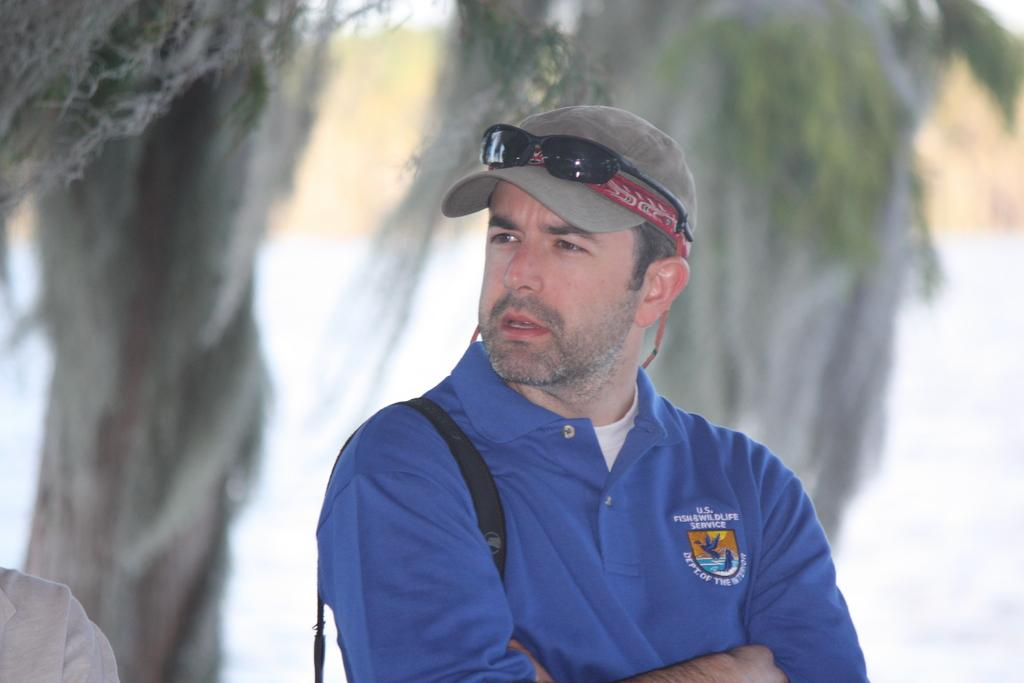Who is present in the image? There is a man in the image. What is the man wearing on his upper body? The man is wearing a blue T-shirt. What type of headwear is the man wearing? The man is wearing a gray cap. Can you describe the background of the image? The background of the image is blurred. What type of box can be seen in the image? There is no box present in the image. Is the man walking on the coast in the image? There is no coast visible in the image, and the man's location is not specified beyond his presence in the image. 